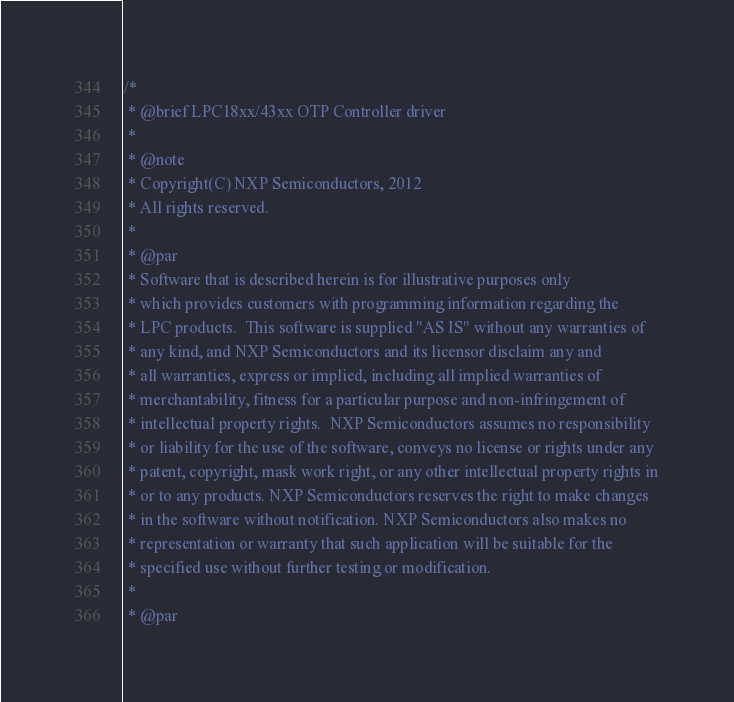<code> <loc_0><loc_0><loc_500><loc_500><_C_>/*
 * @brief LPC18xx/43xx OTP Controller driver
 *
 * @note
 * Copyright(C) NXP Semiconductors, 2012
 * All rights reserved.
 *
 * @par
 * Software that is described herein is for illustrative purposes only
 * which provides customers with programming information regarding the
 * LPC products.  This software is supplied "AS IS" without any warranties of
 * any kind, and NXP Semiconductors and its licensor disclaim any and
 * all warranties, express or implied, including all implied warranties of
 * merchantability, fitness for a particular purpose and non-infringement of
 * intellectual property rights.  NXP Semiconductors assumes no responsibility
 * or liability for the use of the software, conveys no license or rights under any
 * patent, copyright, mask work right, or any other intellectual property rights in
 * or to any products. NXP Semiconductors reserves the right to make changes
 * in the software without notification. NXP Semiconductors also makes no
 * representation or warranty that such application will be suitable for the
 * specified use without further testing or modification.
 *
 * @par</code> 